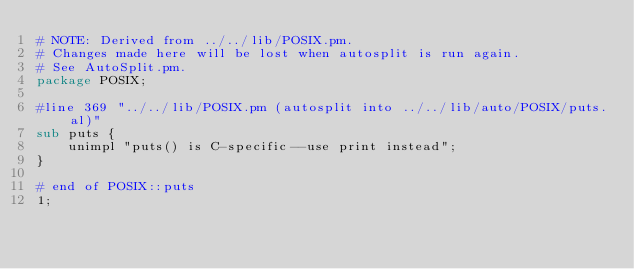<code> <loc_0><loc_0><loc_500><loc_500><_Perl_># NOTE: Derived from ../../lib/POSIX.pm.
# Changes made here will be lost when autosplit is run again.
# See AutoSplit.pm.
package POSIX;

#line 369 "../../lib/POSIX.pm (autosplit into ../../lib/auto/POSIX/puts.al)"
sub puts {
    unimpl "puts() is C-specific--use print instead";
}

# end of POSIX::puts
1;
</code> 